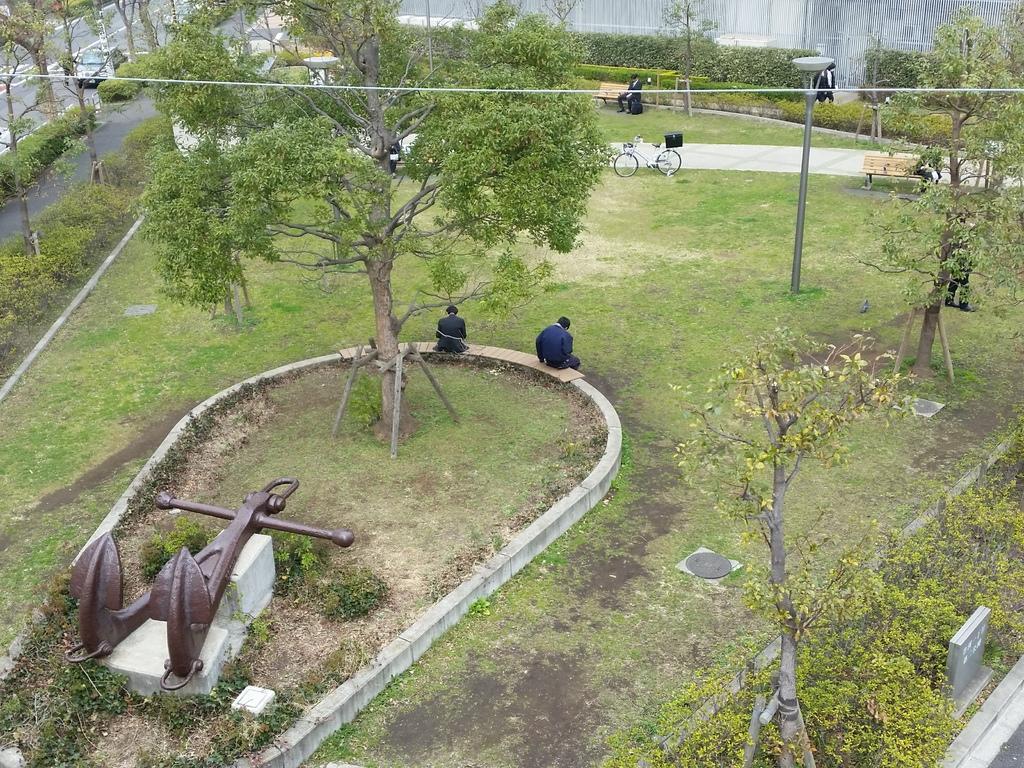How would you summarize this image in a sentence or two? In the center of the image we can see the trees, ground, some persons, poles, wire, benches. At the bottom of the image we can see an equipment, boards. In the top left corner we can see a vehicle and road. At the top of the image we can see the wall. 